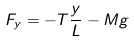Convert formula to latex. <formula><loc_0><loc_0><loc_500><loc_500>F _ { y } = - T \frac { y } { L } - M g</formula> 